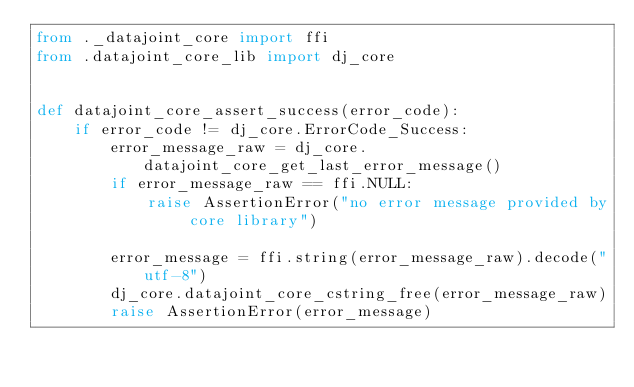Convert code to text. <code><loc_0><loc_0><loc_500><loc_500><_Python_>from ._datajoint_core import ffi
from .datajoint_core_lib import dj_core


def datajoint_core_assert_success(error_code):
    if error_code != dj_core.ErrorCode_Success:
        error_message_raw = dj_core.datajoint_core_get_last_error_message()
        if error_message_raw == ffi.NULL:
            raise AssertionError("no error message provided by core library")

        error_message = ffi.string(error_message_raw).decode("utf-8")
        dj_core.datajoint_core_cstring_free(error_message_raw)
        raise AssertionError(error_message)
</code> 